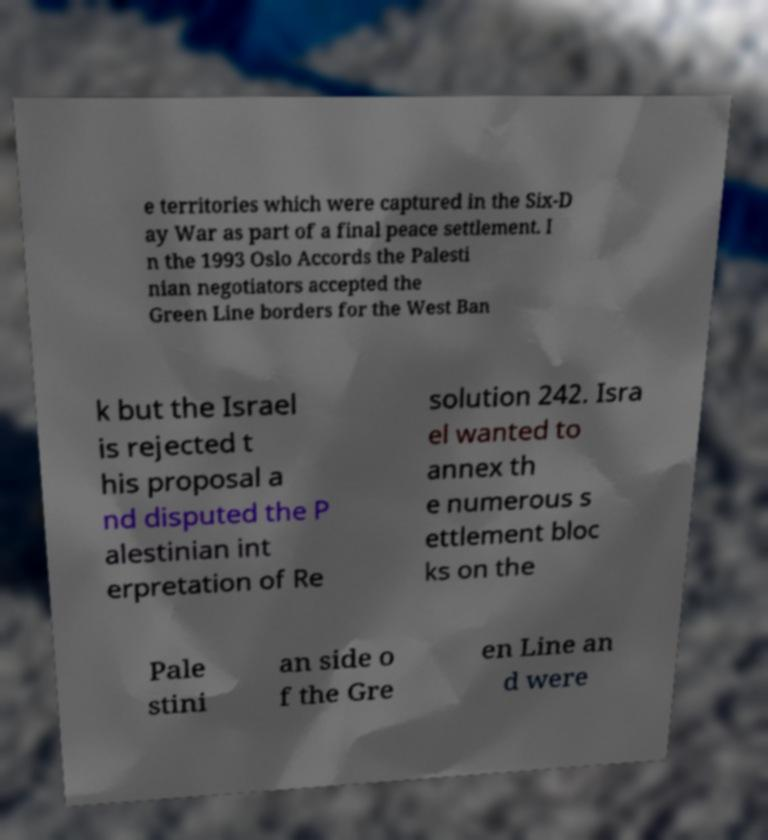There's text embedded in this image that I need extracted. Can you transcribe it verbatim? e territories which were captured in the Six-D ay War as part of a final peace settlement. I n the 1993 Oslo Accords the Palesti nian negotiators accepted the Green Line borders for the West Ban k but the Israel is rejected t his proposal a nd disputed the P alestinian int erpretation of Re solution 242. Isra el wanted to annex th e numerous s ettlement bloc ks on the Pale stini an side o f the Gre en Line an d were 